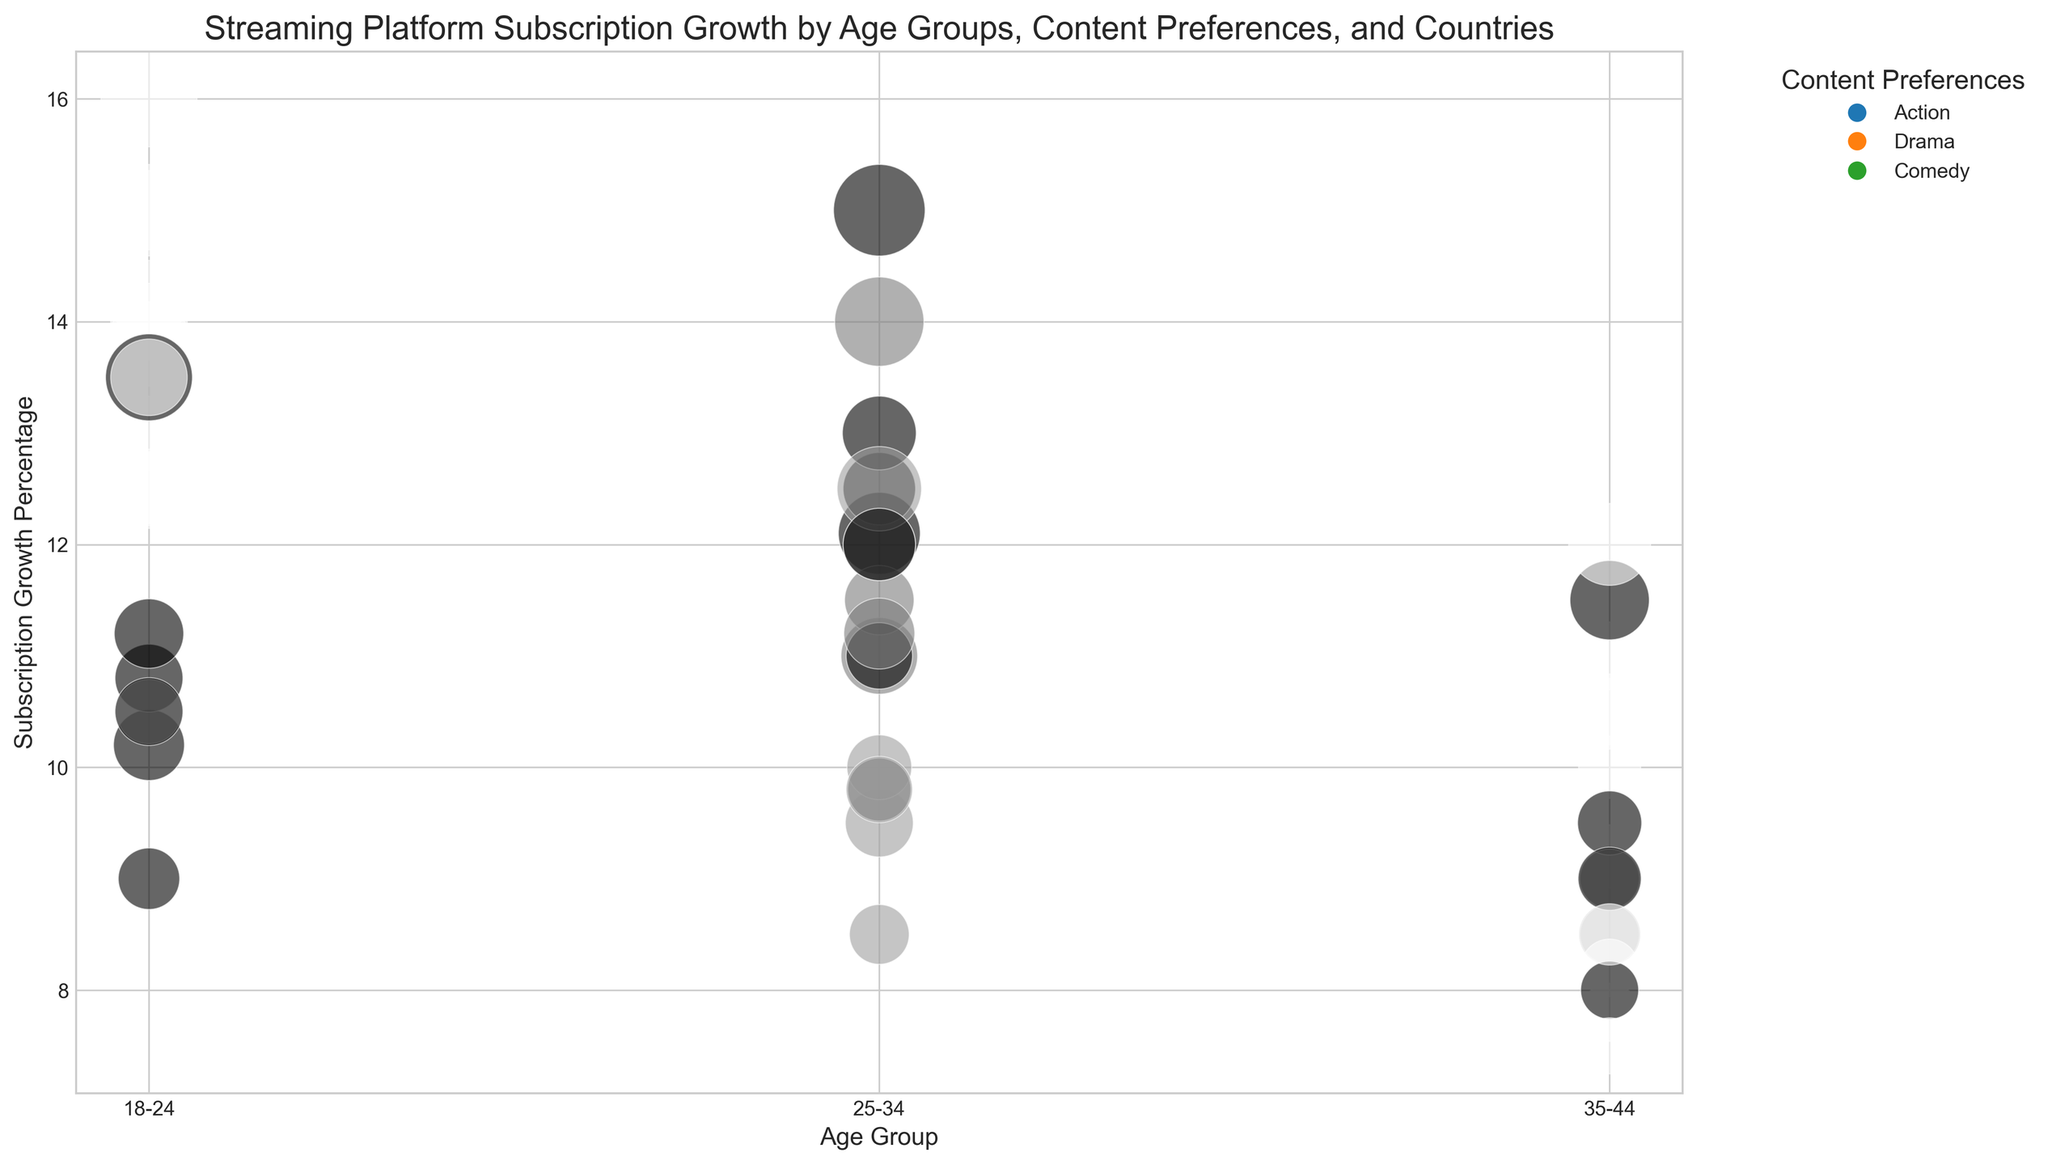What's the country with the highest subscription growth percentage for the 18-24 age group and comedy content? Look for the largest bubble in the 18-24 age group for comedy content, which is colored consistently. India's bubble is the largest.
Answer: India Which country has the lowest subscription growth percentage for drama content across all age groups? Identify the smallest bubble or the lowest point along the Subscription Growth Percentage axis for drama content. Germany's bubbles are consistently lower.
Answer: Germany What is the difference in subscription growth percentage between action and comedy content for the 35-44 age group in Australia? Locate Australia’s 35-44 age group and find the bubbles for action and comedy. Comedy has 10.5%, and action has 9%. The difference is 10.5% - 9%.
Answer: 1.5% Which age group in Canada has the highest number of subscribers for action content? Look for the largest bubble in the action content category for Canada across all age groups. The 18-24 age group has the largest bubble.
Answer: 18-24 Which content preference has the highest subscription growth percentage in the UK for the 25-34 age group? Compare bubbles for action, drama, and comedy in the UK’s 25-34 age group. Comedy’s bubble is the highest.
Answer: Comedy What’s the average subscription growth percentage for comedy content in India across all age groups? Add the subscription growth percentages for comedy in India (16% for 18-24, 15% for 25-34, and 12% for 35-44) and divide by 3.
Answer: 14.33% Which age group in the USA has the smallest bubble for drama content? Compare the bubble sizes for drama content across the age groups in the USA. The smallest bubble is in the 35-44 age group.
Answer: 35-44 Compare the subscription growth percentages for action content between the 18-24 age group in Canada and Germany. Which country has a higher percentage? Look at the bubbles for action content for the 18-24 age group in both countries. Canada’s growth is 14%, and Germany's is 10.5%. Canada has a higher percentage.
Answer: Canada Which country’s 25-34 age group shows a larger bubble for drama content compared to the 35-44 age group? Find the drama content bubbles for the 25-34 and 35-44 age groups across the different countries. In the USA, the 25-34 bubble is larger than 35-44.
Answer: USA 